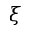Convert formula to latex. <formula><loc_0><loc_0><loc_500><loc_500>\xi</formula> 